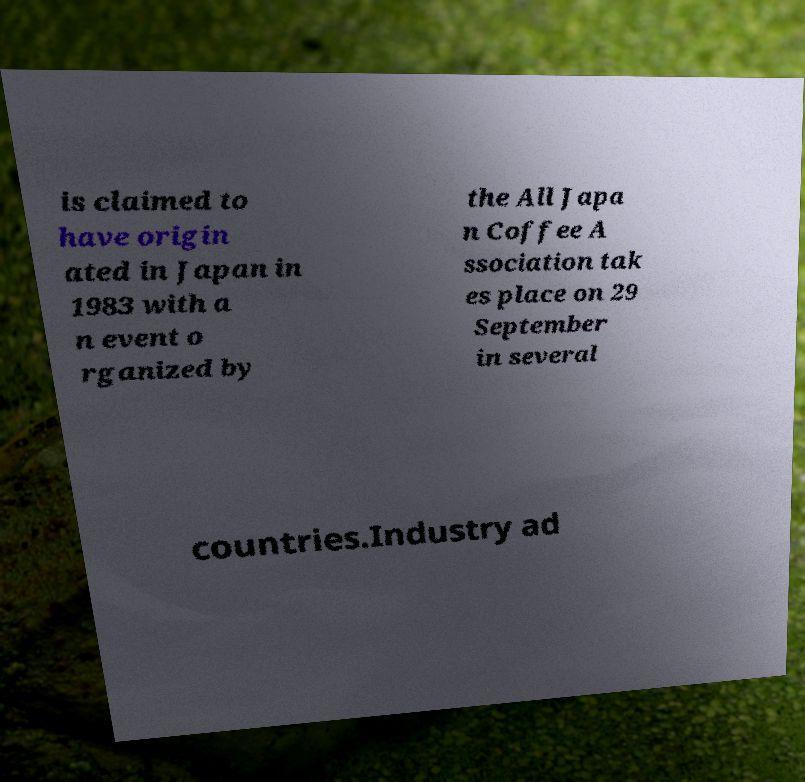For documentation purposes, I need the text within this image transcribed. Could you provide that? is claimed to have origin ated in Japan in 1983 with a n event o rganized by the All Japa n Coffee A ssociation tak es place on 29 September in several countries.Industry ad 